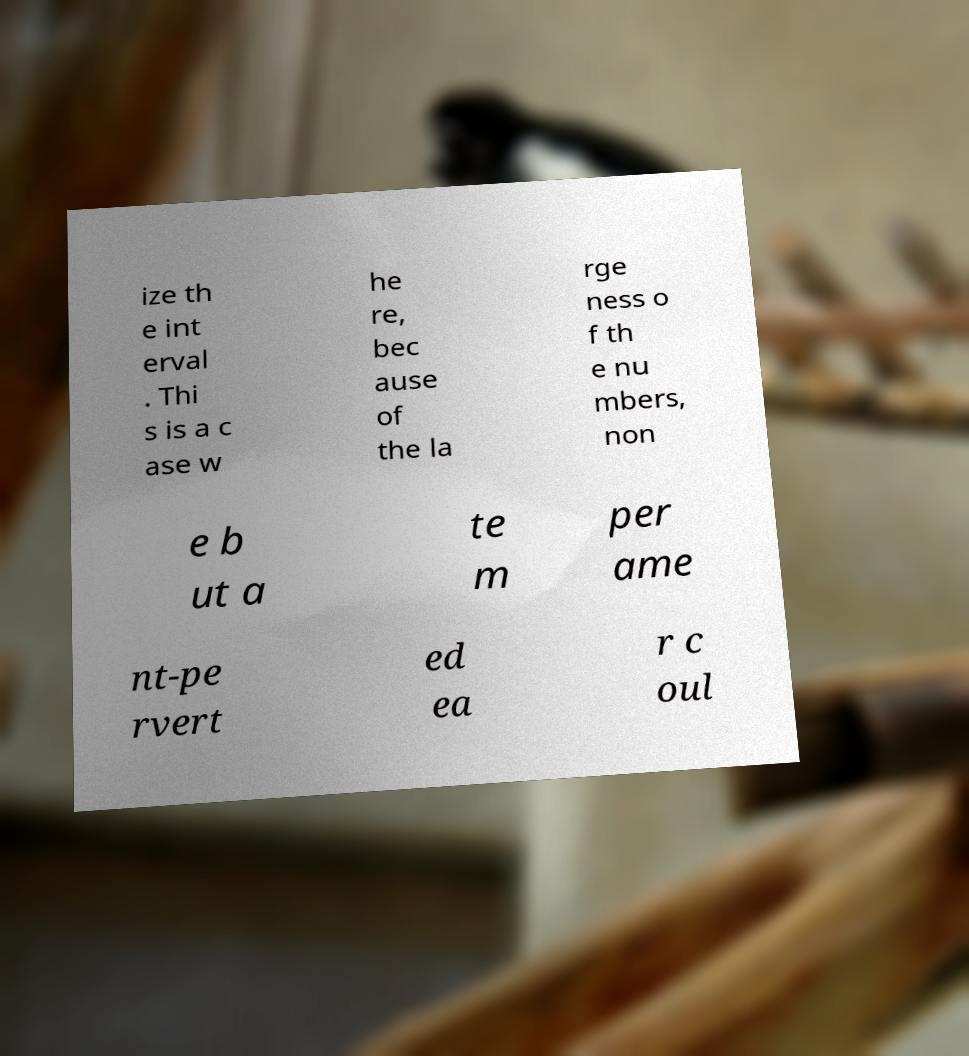Please identify and transcribe the text found in this image. ize th e int erval . Thi s is a c ase w he re, bec ause of the la rge ness o f th e nu mbers, non e b ut a te m per ame nt-pe rvert ed ea r c oul 